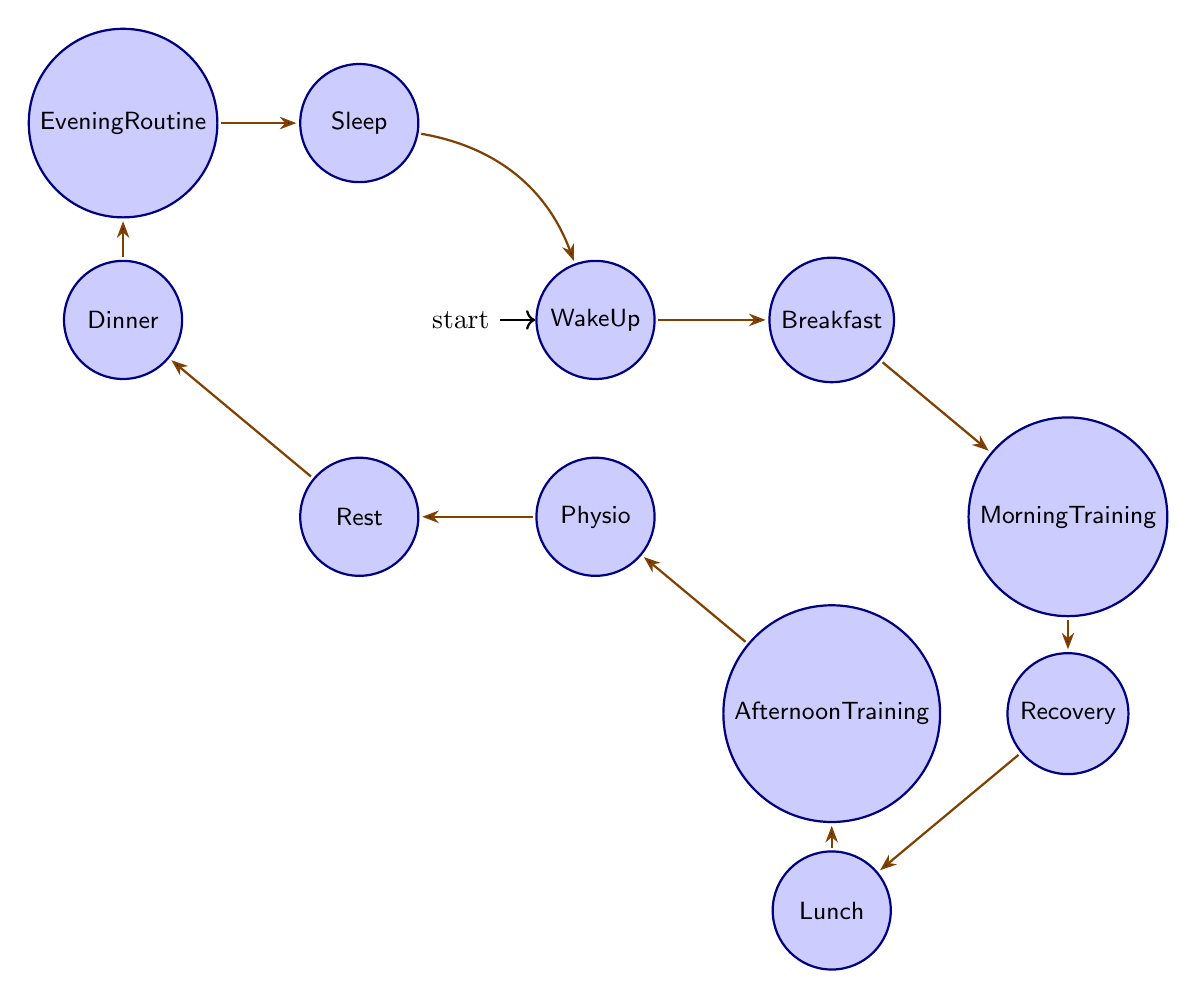What is the first state in the schedule? The first state in the schedule is represented by the initial node called "WakeUp." This node is where the day begins and indicates the starting point of the finite state machine.
Answer: WakeUp How many total states are there in the diagram? To find the total number of states, we count each unique node represented in the diagram. There are 11 distinct nodes, including WakeUp and Sleep.
Answer: 11 What follows the "Recovery" state? Following the "Recovery" state, the diagram transitions to the "Lunch" state. This means that after completing recovery activities, the next task is to have lunch.
Answer: Lunch Which state comes after the "Afternoon Training Session"? The state that comes after the "Afternoon Training Session" is "Physiotherapy," indicating that following the second training, there is a scheduled physiotherapy session.
Answer: Physiotherapy What is the last state in the diagram? The last state in the diagram is "Sleep," which indicates that the day's activities conclude with going to bed for rest.
Answer: Sleep How many transitions occur between states? The total number of transitions can be counted by looking at the paths leading from one node to another. There are 10 transitions in the diagram, connecting all the states in sequence.
Answer: 10 What state is directly before "Dinner"? The state directly before "Dinner" is "Rest," which indicates that the athlete engages in relaxation or light napping before proceeding to dinner.
Answer: Rest What is the transition from "Recovery" to "Lunch"? The transition from "Recovery" to "Lunch" is a progression to the next step in the daily schedule after the recovery activities are completed.
Answer: Lunch Which state reflects the evening activities? The state that reflects the evening activities is "Evening Routine," where the athlete reviews training performance and plans for the next day.
Answer: Evening Routine 